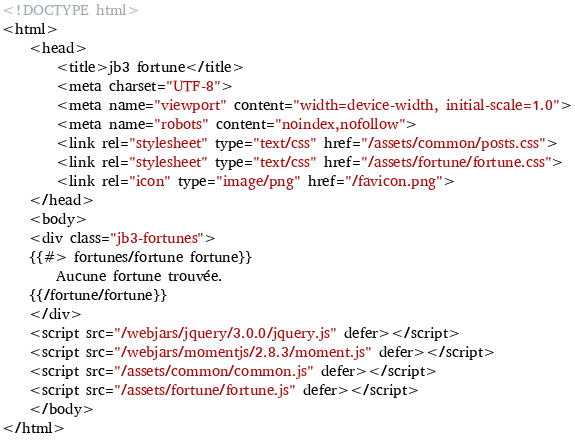Convert code to text. <code><loc_0><loc_0><loc_500><loc_500><_HTML_><!DOCTYPE html>
<html>
    <head>
        <title>jb3 fortune</title>
        <meta charset="UTF-8">
        <meta name="viewport" content="width=device-width, initial-scale=1.0">
        <meta name="robots" content="noindex,nofollow">
        <link rel="stylesheet" type="text/css" href="/assets/common/posts.css">
        <link rel="stylesheet" type="text/css" href="/assets/fortune/fortune.css">
        <link rel="icon" type="image/png" href="/favicon.png">
    </head>
    <body>
    <div class="jb3-fortunes">
    {{#> fortunes/fortune fortune}}
        Aucune fortune trouvée.
    {{/fortune/fortune}}
    </div>
    <script src="/webjars/jquery/3.0.0/jquery.js" defer></script>
    <script src="/webjars/momentjs/2.8.3/moment.js" defer></script>
    <script src="/assets/common/common.js" defer></script>
    <script src="/assets/fortune/fortune.js" defer></script>
    </body>
</html></code> 